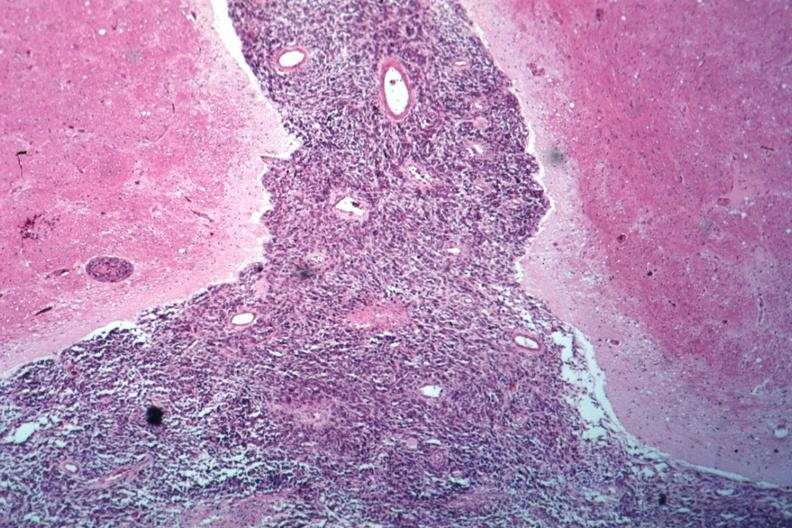s brain present?
Answer the question using a single word or phrase. Yes 